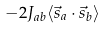Convert formula to latex. <formula><loc_0><loc_0><loc_500><loc_500>\ - 2 J _ { a b } \langle { \vec { s } } _ { a } \cdot { \vec { s } } _ { b } \rangle</formula> 